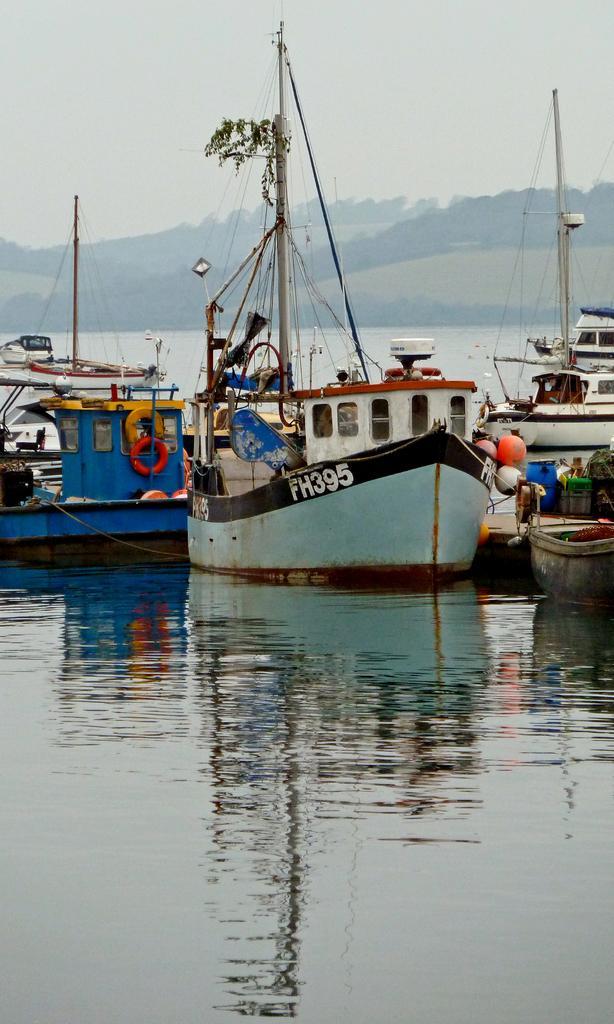Could you give a brief overview of what you see in this image? In this image I can see few boats on the water. I can see some orange and red color tubes to the boats. These boots are in different colors. I can also see some ropes to the boats. In the background I can see the mountains and the sky. 